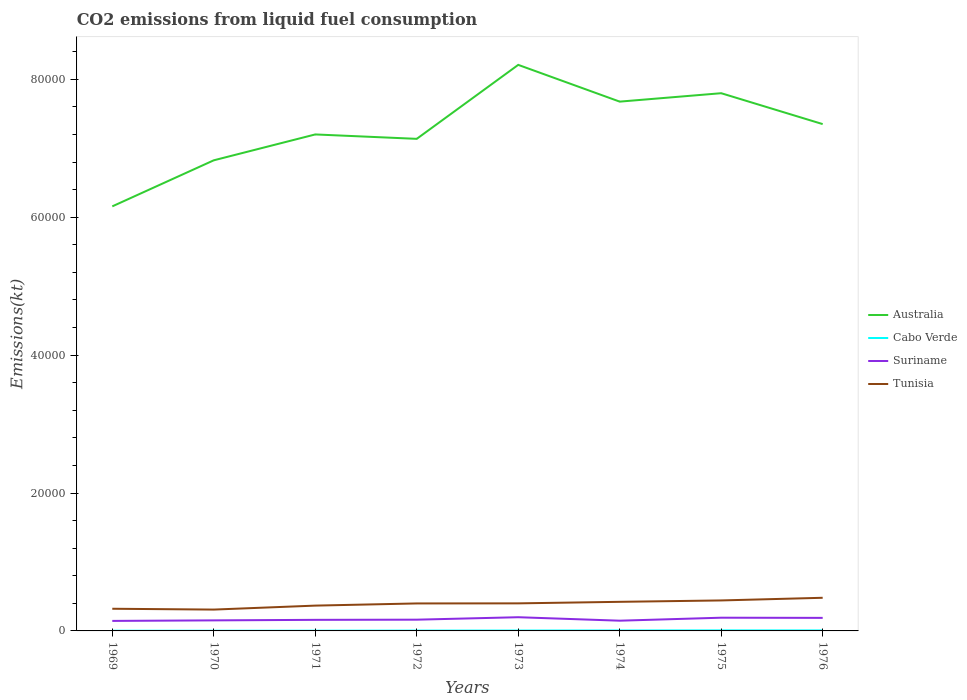Across all years, what is the maximum amount of CO2 emitted in Tunisia?
Ensure brevity in your answer.  3094.95. In which year was the amount of CO2 emitted in Cabo Verde maximum?
Keep it short and to the point. 1969. What is the total amount of CO2 emitted in Cabo Verde in the graph?
Ensure brevity in your answer.  0. What is the difference between the highest and the second highest amount of CO2 emitted in Australia?
Give a very brief answer. 2.05e+04. What is the difference between the highest and the lowest amount of CO2 emitted in Tunisia?
Provide a succinct answer. 5. Is the amount of CO2 emitted in Cabo Verde strictly greater than the amount of CO2 emitted in Tunisia over the years?
Your answer should be very brief. Yes. How many years are there in the graph?
Your answer should be very brief. 8. What is the difference between two consecutive major ticks on the Y-axis?
Offer a very short reply. 2.00e+04. Does the graph contain grids?
Keep it short and to the point. No. How many legend labels are there?
Ensure brevity in your answer.  4. What is the title of the graph?
Give a very brief answer. CO2 emissions from liquid fuel consumption. Does "Poland" appear as one of the legend labels in the graph?
Ensure brevity in your answer.  No. What is the label or title of the X-axis?
Make the answer very short. Years. What is the label or title of the Y-axis?
Make the answer very short. Emissions(kt). What is the Emissions(kt) in Australia in 1969?
Give a very brief answer. 6.16e+04. What is the Emissions(kt) of Cabo Verde in 1969?
Provide a short and direct response. 29.34. What is the Emissions(kt) of Suriname in 1969?
Ensure brevity in your answer.  1452.13. What is the Emissions(kt) of Tunisia in 1969?
Offer a terse response. 3215.96. What is the Emissions(kt) of Australia in 1970?
Make the answer very short. 6.83e+04. What is the Emissions(kt) in Cabo Verde in 1970?
Give a very brief answer. 29.34. What is the Emissions(kt) in Suriname in 1970?
Provide a succinct answer. 1529.14. What is the Emissions(kt) of Tunisia in 1970?
Provide a short and direct response. 3094.95. What is the Emissions(kt) of Australia in 1971?
Provide a succinct answer. 7.20e+04. What is the Emissions(kt) in Cabo Verde in 1971?
Make the answer very short. 33. What is the Emissions(kt) of Suriname in 1971?
Offer a terse response. 1606.15. What is the Emissions(kt) in Tunisia in 1971?
Keep it short and to the point. 3670.67. What is the Emissions(kt) in Australia in 1972?
Your response must be concise. 7.14e+04. What is the Emissions(kt) in Cabo Verde in 1972?
Offer a terse response. 47.67. What is the Emissions(kt) in Suriname in 1972?
Provide a succinct answer. 1631.82. What is the Emissions(kt) in Tunisia in 1972?
Give a very brief answer. 3986.03. What is the Emissions(kt) of Australia in 1973?
Offer a terse response. 8.21e+04. What is the Emissions(kt) of Cabo Verde in 1973?
Offer a very short reply. 55.01. What is the Emissions(kt) of Suriname in 1973?
Keep it short and to the point. 1987.51. What is the Emissions(kt) of Tunisia in 1973?
Provide a short and direct response. 3997.03. What is the Emissions(kt) of Australia in 1974?
Ensure brevity in your answer.  7.68e+04. What is the Emissions(kt) in Cabo Verde in 1974?
Offer a terse response. 66.01. What is the Emissions(kt) in Suriname in 1974?
Provide a succinct answer. 1485.13. What is the Emissions(kt) in Tunisia in 1974?
Make the answer very short. 4220.72. What is the Emissions(kt) of Australia in 1975?
Offer a very short reply. 7.80e+04. What is the Emissions(kt) in Cabo Verde in 1975?
Keep it short and to the point. 77.01. What is the Emissions(kt) in Suriname in 1975?
Provide a succinct answer. 1917.84. What is the Emissions(kt) in Tunisia in 1975?
Your answer should be very brief. 4422.4. What is the Emissions(kt) of Australia in 1976?
Offer a very short reply. 7.35e+04. What is the Emissions(kt) of Cabo Verde in 1976?
Keep it short and to the point. 73.34. What is the Emissions(kt) in Suriname in 1976?
Provide a short and direct response. 1892.17. What is the Emissions(kt) of Tunisia in 1976?
Give a very brief answer. 4807.44. Across all years, what is the maximum Emissions(kt) in Australia?
Your answer should be compact. 8.21e+04. Across all years, what is the maximum Emissions(kt) in Cabo Verde?
Your answer should be very brief. 77.01. Across all years, what is the maximum Emissions(kt) in Suriname?
Keep it short and to the point. 1987.51. Across all years, what is the maximum Emissions(kt) in Tunisia?
Provide a short and direct response. 4807.44. Across all years, what is the minimum Emissions(kt) in Australia?
Your answer should be very brief. 6.16e+04. Across all years, what is the minimum Emissions(kt) in Cabo Verde?
Provide a succinct answer. 29.34. Across all years, what is the minimum Emissions(kt) of Suriname?
Provide a succinct answer. 1452.13. Across all years, what is the minimum Emissions(kt) of Tunisia?
Provide a succinct answer. 3094.95. What is the total Emissions(kt) in Australia in the graph?
Offer a terse response. 5.84e+05. What is the total Emissions(kt) in Cabo Verde in the graph?
Your answer should be compact. 410.7. What is the total Emissions(kt) in Suriname in the graph?
Make the answer very short. 1.35e+04. What is the total Emissions(kt) of Tunisia in the graph?
Offer a very short reply. 3.14e+04. What is the difference between the Emissions(kt) in Australia in 1969 and that in 1970?
Keep it short and to the point. -6681.27. What is the difference between the Emissions(kt) in Suriname in 1969 and that in 1970?
Provide a succinct answer. -77.01. What is the difference between the Emissions(kt) of Tunisia in 1969 and that in 1970?
Make the answer very short. 121.01. What is the difference between the Emissions(kt) in Australia in 1969 and that in 1971?
Your answer should be compact. -1.04e+04. What is the difference between the Emissions(kt) in Cabo Verde in 1969 and that in 1971?
Give a very brief answer. -3.67. What is the difference between the Emissions(kt) in Suriname in 1969 and that in 1971?
Your answer should be very brief. -154.01. What is the difference between the Emissions(kt) of Tunisia in 1969 and that in 1971?
Your answer should be very brief. -454.71. What is the difference between the Emissions(kt) in Australia in 1969 and that in 1972?
Offer a terse response. -9794.56. What is the difference between the Emissions(kt) in Cabo Verde in 1969 and that in 1972?
Your answer should be compact. -18.34. What is the difference between the Emissions(kt) in Suriname in 1969 and that in 1972?
Offer a very short reply. -179.68. What is the difference between the Emissions(kt) in Tunisia in 1969 and that in 1972?
Ensure brevity in your answer.  -770.07. What is the difference between the Emissions(kt) of Australia in 1969 and that in 1973?
Offer a terse response. -2.05e+04. What is the difference between the Emissions(kt) of Cabo Verde in 1969 and that in 1973?
Keep it short and to the point. -25.67. What is the difference between the Emissions(kt) in Suriname in 1969 and that in 1973?
Provide a short and direct response. -535.38. What is the difference between the Emissions(kt) in Tunisia in 1969 and that in 1973?
Offer a very short reply. -781.07. What is the difference between the Emissions(kt) of Australia in 1969 and that in 1974?
Make the answer very short. -1.52e+04. What is the difference between the Emissions(kt) of Cabo Verde in 1969 and that in 1974?
Provide a short and direct response. -36.67. What is the difference between the Emissions(kt) of Suriname in 1969 and that in 1974?
Ensure brevity in your answer.  -33. What is the difference between the Emissions(kt) in Tunisia in 1969 and that in 1974?
Ensure brevity in your answer.  -1004.76. What is the difference between the Emissions(kt) of Australia in 1969 and that in 1975?
Offer a very short reply. -1.64e+04. What is the difference between the Emissions(kt) of Cabo Verde in 1969 and that in 1975?
Ensure brevity in your answer.  -47.67. What is the difference between the Emissions(kt) in Suriname in 1969 and that in 1975?
Make the answer very short. -465.71. What is the difference between the Emissions(kt) of Tunisia in 1969 and that in 1975?
Provide a succinct answer. -1206.44. What is the difference between the Emissions(kt) of Australia in 1969 and that in 1976?
Provide a succinct answer. -1.19e+04. What is the difference between the Emissions(kt) of Cabo Verde in 1969 and that in 1976?
Give a very brief answer. -44. What is the difference between the Emissions(kt) in Suriname in 1969 and that in 1976?
Provide a short and direct response. -440.04. What is the difference between the Emissions(kt) of Tunisia in 1969 and that in 1976?
Provide a succinct answer. -1591.48. What is the difference between the Emissions(kt) in Australia in 1970 and that in 1971?
Make the answer very short. -3751.34. What is the difference between the Emissions(kt) of Cabo Verde in 1970 and that in 1971?
Your answer should be compact. -3.67. What is the difference between the Emissions(kt) of Suriname in 1970 and that in 1971?
Your answer should be compact. -77.01. What is the difference between the Emissions(kt) in Tunisia in 1970 and that in 1971?
Provide a short and direct response. -575.72. What is the difference between the Emissions(kt) in Australia in 1970 and that in 1972?
Your answer should be compact. -3113.28. What is the difference between the Emissions(kt) in Cabo Verde in 1970 and that in 1972?
Make the answer very short. -18.34. What is the difference between the Emissions(kt) in Suriname in 1970 and that in 1972?
Make the answer very short. -102.68. What is the difference between the Emissions(kt) of Tunisia in 1970 and that in 1972?
Your response must be concise. -891.08. What is the difference between the Emissions(kt) of Australia in 1970 and that in 1973?
Make the answer very short. -1.38e+04. What is the difference between the Emissions(kt) in Cabo Verde in 1970 and that in 1973?
Your answer should be very brief. -25.67. What is the difference between the Emissions(kt) in Suriname in 1970 and that in 1973?
Keep it short and to the point. -458.38. What is the difference between the Emissions(kt) in Tunisia in 1970 and that in 1973?
Your answer should be very brief. -902.08. What is the difference between the Emissions(kt) in Australia in 1970 and that in 1974?
Your answer should be very brief. -8511.11. What is the difference between the Emissions(kt) of Cabo Verde in 1970 and that in 1974?
Provide a short and direct response. -36.67. What is the difference between the Emissions(kt) in Suriname in 1970 and that in 1974?
Your answer should be compact. 44. What is the difference between the Emissions(kt) of Tunisia in 1970 and that in 1974?
Your answer should be compact. -1125.77. What is the difference between the Emissions(kt) of Australia in 1970 and that in 1975?
Keep it short and to the point. -9732.22. What is the difference between the Emissions(kt) in Cabo Verde in 1970 and that in 1975?
Provide a short and direct response. -47.67. What is the difference between the Emissions(kt) in Suriname in 1970 and that in 1975?
Provide a succinct answer. -388.7. What is the difference between the Emissions(kt) of Tunisia in 1970 and that in 1975?
Offer a very short reply. -1327.45. What is the difference between the Emissions(kt) of Australia in 1970 and that in 1976?
Offer a very short reply. -5251.14. What is the difference between the Emissions(kt) of Cabo Verde in 1970 and that in 1976?
Give a very brief answer. -44. What is the difference between the Emissions(kt) of Suriname in 1970 and that in 1976?
Your answer should be compact. -363.03. What is the difference between the Emissions(kt) of Tunisia in 1970 and that in 1976?
Ensure brevity in your answer.  -1712.49. What is the difference between the Emissions(kt) of Australia in 1971 and that in 1972?
Keep it short and to the point. 638.06. What is the difference between the Emissions(kt) in Cabo Verde in 1971 and that in 1972?
Provide a succinct answer. -14.67. What is the difference between the Emissions(kt) in Suriname in 1971 and that in 1972?
Your answer should be very brief. -25.67. What is the difference between the Emissions(kt) of Tunisia in 1971 and that in 1972?
Your response must be concise. -315.36. What is the difference between the Emissions(kt) in Australia in 1971 and that in 1973?
Offer a very short reply. -1.01e+04. What is the difference between the Emissions(kt) of Cabo Verde in 1971 and that in 1973?
Provide a succinct answer. -22. What is the difference between the Emissions(kt) in Suriname in 1971 and that in 1973?
Ensure brevity in your answer.  -381.37. What is the difference between the Emissions(kt) of Tunisia in 1971 and that in 1973?
Make the answer very short. -326.36. What is the difference between the Emissions(kt) in Australia in 1971 and that in 1974?
Give a very brief answer. -4759.77. What is the difference between the Emissions(kt) of Cabo Verde in 1971 and that in 1974?
Your response must be concise. -33. What is the difference between the Emissions(kt) in Suriname in 1971 and that in 1974?
Give a very brief answer. 121.01. What is the difference between the Emissions(kt) of Tunisia in 1971 and that in 1974?
Your response must be concise. -550.05. What is the difference between the Emissions(kt) of Australia in 1971 and that in 1975?
Offer a terse response. -5980.88. What is the difference between the Emissions(kt) of Cabo Verde in 1971 and that in 1975?
Give a very brief answer. -44. What is the difference between the Emissions(kt) in Suriname in 1971 and that in 1975?
Your response must be concise. -311.69. What is the difference between the Emissions(kt) of Tunisia in 1971 and that in 1975?
Give a very brief answer. -751.74. What is the difference between the Emissions(kt) in Australia in 1971 and that in 1976?
Offer a very short reply. -1499.8. What is the difference between the Emissions(kt) of Cabo Verde in 1971 and that in 1976?
Your answer should be compact. -40.34. What is the difference between the Emissions(kt) in Suriname in 1971 and that in 1976?
Make the answer very short. -286.03. What is the difference between the Emissions(kt) in Tunisia in 1971 and that in 1976?
Your answer should be compact. -1136.77. What is the difference between the Emissions(kt) in Australia in 1972 and that in 1973?
Offer a very short reply. -1.07e+04. What is the difference between the Emissions(kt) of Cabo Verde in 1972 and that in 1973?
Your response must be concise. -7.33. What is the difference between the Emissions(kt) of Suriname in 1972 and that in 1973?
Offer a very short reply. -355.7. What is the difference between the Emissions(kt) in Tunisia in 1972 and that in 1973?
Your answer should be compact. -11. What is the difference between the Emissions(kt) of Australia in 1972 and that in 1974?
Offer a terse response. -5397.82. What is the difference between the Emissions(kt) in Cabo Verde in 1972 and that in 1974?
Give a very brief answer. -18.34. What is the difference between the Emissions(kt) in Suriname in 1972 and that in 1974?
Your response must be concise. 146.68. What is the difference between the Emissions(kt) in Tunisia in 1972 and that in 1974?
Provide a succinct answer. -234.69. What is the difference between the Emissions(kt) in Australia in 1972 and that in 1975?
Offer a very short reply. -6618.94. What is the difference between the Emissions(kt) in Cabo Verde in 1972 and that in 1975?
Offer a terse response. -29.34. What is the difference between the Emissions(kt) in Suriname in 1972 and that in 1975?
Offer a very short reply. -286.03. What is the difference between the Emissions(kt) of Tunisia in 1972 and that in 1975?
Provide a succinct answer. -436.37. What is the difference between the Emissions(kt) in Australia in 1972 and that in 1976?
Keep it short and to the point. -2137.86. What is the difference between the Emissions(kt) in Cabo Verde in 1972 and that in 1976?
Offer a terse response. -25.67. What is the difference between the Emissions(kt) in Suriname in 1972 and that in 1976?
Your answer should be very brief. -260.36. What is the difference between the Emissions(kt) of Tunisia in 1972 and that in 1976?
Keep it short and to the point. -821.41. What is the difference between the Emissions(kt) of Australia in 1973 and that in 1974?
Make the answer very short. 5331.82. What is the difference between the Emissions(kt) in Cabo Verde in 1973 and that in 1974?
Make the answer very short. -11. What is the difference between the Emissions(kt) of Suriname in 1973 and that in 1974?
Give a very brief answer. 502.38. What is the difference between the Emissions(kt) of Tunisia in 1973 and that in 1974?
Provide a short and direct response. -223.69. What is the difference between the Emissions(kt) in Australia in 1973 and that in 1975?
Keep it short and to the point. 4110.71. What is the difference between the Emissions(kt) of Cabo Verde in 1973 and that in 1975?
Offer a terse response. -22. What is the difference between the Emissions(kt) in Suriname in 1973 and that in 1975?
Give a very brief answer. 69.67. What is the difference between the Emissions(kt) of Tunisia in 1973 and that in 1975?
Make the answer very short. -425.37. What is the difference between the Emissions(kt) in Australia in 1973 and that in 1976?
Your answer should be very brief. 8591.78. What is the difference between the Emissions(kt) in Cabo Verde in 1973 and that in 1976?
Provide a succinct answer. -18.34. What is the difference between the Emissions(kt) of Suriname in 1973 and that in 1976?
Offer a very short reply. 95.34. What is the difference between the Emissions(kt) in Tunisia in 1973 and that in 1976?
Make the answer very short. -810.41. What is the difference between the Emissions(kt) of Australia in 1974 and that in 1975?
Your answer should be compact. -1221.11. What is the difference between the Emissions(kt) in Cabo Verde in 1974 and that in 1975?
Provide a short and direct response. -11. What is the difference between the Emissions(kt) of Suriname in 1974 and that in 1975?
Ensure brevity in your answer.  -432.71. What is the difference between the Emissions(kt) in Tunisia in 1974 and that in 1975?
Your response must be concise. -201.69. What is the difference between the Emissions(kt) of Australia in 1974 and that in 1976?
Ensure brevity in your answer.  3259.96. What is the difference between the Emissions(kt) of Cabo Verde in 1974 and that in 1976?
Your answer should be very brief. -7.33. What is the difference between the Emissions(kt) of Suriname in 1974 and that in 1976?
Give a very brief answer. -407.04. What is the difference between the Emissions(kt) of Tunisia in 1974 and that in 1976?
Offer a terse response. -586.72. What is the difference between the Emissions(kt) in Australia in 1975 and that in 1976?
Make the answer very short. 4481.07. What is the difference between the Emissions(kt) of Cabo Verde in 1975 and that in 1976?
Give a very brief answer. 3.67. What is the difference between the Emissions(kt) of Suriname in 1975 and that in 1976?
Provide a short and direct response. 25.67. What is the difference between the Emissions(kt) of Tunisia in 1975 and that in 1976?
Keep it short and to the point. -385.04. What is the difference between the Emissions(kt) of Australia in 1969 and the Emissions(kt) of Cabo Verde in 1970?
Offer a very short reply. 6.16e+04. What is the difference between the Emissions(kt) in Australia in 1969 and the Emissions(kt) in Suriname in 1970?
Give a very brief answer. 6.01e+04. What is the difference between the Emissions(kt) of Australia in 1969 and the Emissions(kt) of Tunisia in 1970?
Your answer should be very brief. 5.85e+04. What is the difference between the Emissions(kt) of Cabo Verde in 1969 and the Emissions(kt) of Suriname in 1970?
Offer a terse response. -1499.8. What is the difference between the Emissions(kt) in Cabo Verde in 1969 and the Emissions(kt) in Tunisia in 1970?
Offer a terse response. -3065.61. What is the difference between the Emissions(kt) in Suriname in 1969 and the Emissions(kt) in Tunisia in 1970?
Provide a succinct answer. -1642.82. What is the difference between the Emissions(kt) in Australia in 1969 and the Emissions(kt) in Cabo Verde in 1971?
Make the answer very short. 6.15e+04. What is the difference between the Emissions(kt) of Australia in 1969 and the Emissions(kt) of Suriname in 1971?
Provide a succinct answer. 6.00e+04. What is the difference between the Emissions(kt) in Australia in 1969 and the Emissions(kt) in Tunisia in 1971?
Ensure brevity in your answer.  5.79e+04. What is the difference between the Emissions(kt) in Cabo Verde in 1969 and the Emissions(kt) in Suriname in 1971?
Make the answer very short. -1576.81. What is the difference between the Emissions(kt) in Cabo Verde in 1969 and the Emissions(kt) in Tunisia in 1971?
Your answer should be very brief. -3641.33. What is the difference between the Emissions(kt) of Suriname in 1969 and the Emissions(kt) of Tunisia in 1971?
Keep it short and to the point. -2218.53. What is the difference between the Emissions(kt) in Australia in 1969 and the Emissions(kt) in Cabo Verde in 1972?
Your answer should be very brief. 6.15e+04. What is the difference between the Emissions(kt) in Australia in 1969 and the Emissions(kt) in Suriname in 1972?
Offer a very short reply. 5.99e+04. What is the difference between the Emissions(kt) of Australia in 1969 and the Emissions(kt) of Tunisia in 1972?
Your response must be concise. 5.76e+04. What is the difference between the Emissions(kt) in Cabo Verde in 1969 and the Emissions(kt) in Suriname in 1972?
Ensure brevity in your answer.  -1602.48. What is the difference between the Emissions(kt) in Cabo Verde in 1969 and the Emissions(kt) in Tunisia in 1972?
Your response must be concise. -3956.69. What is the difference between the Emissions(kt) of Suriname in 1969 and the Emissions(kt) of Tunisia in 1972?
Your answer should be very brief. -2533.9. What is the difference between the Emissions(kt) of Australia in 1969 and the Emissions(kt) of Cabo Verde in 1973?
Ensure brevity in your answer.  6.15e+04. What is the difference between the Emissions(kt) of Australia in 1969 and the Emissions(kt) of Suriname in 1973?
Keep it short and to the point. 5.96e+04. What is the difference between the Emissions(kt) in Australia in 1969 and the Emissions(kt) in Tunisia in 1973?
Provide a succinct answer. 5.76e+04. What is the difference between the Emissions(kt) of Cabo Verde in 1969 and the Emissions(kt) of Suriname in 1973?
Your answer should be very brief. -1958.18. What is the difference between the Emissions(kt) in Cabo Verde in 1969 and the Emissions(kt) in Tunisia in 1973?
Your response must be concise. -3967.69. What is the difference between the Emissions(kt) of Suriname in 1969 and the Emissions(kt) of Tunisia in 1973?
Ensure brevity in your answer.  -2544.9. What is the difference between the Emissions(kt) in Australia in 1969 and the Emissions(kt) in Cabo Verde in 1974?
Ensure brevity in your answer.  6.15e+04. What is the difference between the Emissions(kt) in Australia in 1969 and the Emissions(kt) in Suriname in 1974?
Your answer should be compact. 6.01e+04. What is the difference between the Emissions(kt) of Australia in 1969 and the Emissions(kt) of Tunisia in 1974?
Make the answer very short. 5.74e+04. What is the difference between the Emissions(kt) of Cabo Verde in 1969 and the Emissions(kt) of Suriname in 1974?
Provide a succinct answer. -1455.8. What is the difference between the Emissions(kt) of Cabo Verde in 1969 and the Emissions(kt) of Tunisia in 1974?
Your answer should be compact. -4191.38. What is the difference between the Emissions(kt) of Suriname in 1969 and the Emissions(kt) of Tunisia in 1974?
Give a very brief answer. -2768.59. What is the difference between the Emissions(kt) of Australia in 1969 and the Emissions(kt) of Cabo Verde in 1975?
Provide a short and direct response. 6.15e+04. What is the difference between the Emissions(kt) in Australia in 1969 and the Emissions(kt) in Suriname in 1975?
Offer a terse response. 5.97e+04. What is the difference between the Emissions(kt) of Australia in 1969 and the Emissions(kt) of Tunisia in 1975?
Offer a terse response. 5.72e+04. What is the difference between the Emissions(kt) in Cabo Verde in 1969 and the Emissions(kt) in Suriname in 1975?
Make the answer very short. -1888.51. What is the difference between the Emissions(kt) in Cabo Verde in 1969 and the Emissions(kt) in Tunisia in 1975?
Give a very brief answer. -4393.07. What is the difference between the Emissions(kt) in Suriname in 1969 and the Emissions(kt) in Tunisia in 1975?
Your answer should be compact. -2970.27. What is the difference between the Emissions(kt) of Australia in 1969 and the Emissions(kt) of Cabo Verde in 1976?
Keep it short and to the point. 6.15e+04. What is the difference between the Emissions(kt) in Australia in 1969 and the Emissions(kt) in Suriname in 1976?
Your answer should be compact. 5.97e+04. What is the difference between the Emissions(kt) of Australia in 1969 and the Emissions(kt) of Tunisia in 1976?
Make the answer very short. 5.68e+04. What is the difference between the Emissions(kt) in Cabo Verde in 1969 and the Emissions(kt) in Suriname in 1976?
Your response must be concise. -1862.84. What is the difference between the Emissions(kt) in Cabo Verde in 1969 and the Emissions(kt) in Tunisia in 1976?
Your answer should be compact. -4778.1. What is the difference between the Emissions(kt) of Suriname in 1969 and the Emissions(kt) of Tunisia in 1976?
Provide a succinct answer. -3355.3. What is the difference between the Emissions(kt) in Australia in 1970 and the Emissions(kt) in Cabo Verde in 1971?
Give a very brief answer. 6.82e+04. What is the difference between the Emissions(kt) of Australia in 1970 and the Emissions(kt) of Suriname in 1971?
Your response must be concise. 6.67e+04. What is the difference between the Emissions(kt) of Australia in 1970 and the Emissions(kt) of Tunisia in 1971?
Offer a very short reply. 6.46e+04. What is the difference between the Emissions(kt) of Cabo Verde in 1970 and the Emissions(kt) of Suriname in 1971?
Offer a terse response. -1576.81. What is the difference between the Emissions(kt) of Cabo Verde in 1970 and the Emissions(kt) of Tunisia in 1971?
Offer a very short reply. -3641.33. What is the difference between the Emissions(kt) of Suriname in 1970 and the Emissions(kt) of Tunisia in 1971?
Keep it short and to the point. -2141.53. What is the difference between the Emissions(kt) of Australia in 1970 and the Emissions(kt) of Cabo Verde in 1972?
Make the answer very short. 6.82e+04. What is the difference between the Emissions(kt) in Australia in 1970 and the Emissions(kt) in Suriname in 1972?
Ensure brevity in your answer.  6.66e+04. What is the difference between the Emissions(kt) in Australia in 1970 and the Emissions(kt) in Tunisia in 1972?
Your answer should be compact. 6.43e+04. What is the difference between the Emissions(kt) of Cabo Verde in 1970 and the Emissions(kt) of Suriname in 1972?
Your response must be concise. -1602.48. What is the difference between the Emissions(kt) of Cabo Verde in 1970 and the Emissions(kt) of Tunisia in 1972?
Your response must be concise. -3956.69. What is the difference between the Emissions(kt) of Suriname in 1970 and the Emissions(kt) of Tunisia in 1972?
Your answer should be compact. -2456.89. What is the difference between the Emissions(kt) in Australia in 1970 and the Emissions(kt) in Cabo Verde in 1973?
Your answer should be very brief. 6.82e+04. What is the difference between the Emissions(kt) in Australia in 1970 and the Emissions(kt) in Suriname in 1973?
Make the answer very short. 6.63e+04. What is the difference between the Emissions(kt) in Australia in 1970 and the Emissions(kt) in Tunisia in 1973?
Provide a succinct answer. 6.43e+04. What is the difference between the Emissions(kt) in Cabo Verde in 1970 and the Emissions(kt) in Suriname in 1973?
Your answer should be compact. -1958.18. What is the difference between the Emissions(kt) of Cabo Verde in 1970 and the Emissions(kt) of Tunisia in 1973?
Ensure brevity in your answer.  -3967.69. What is the difference between the Emissions(kt) of Suriname in 1970 and the Emissions(kt) of Tunisia in 1973?
Offer a terse response. -2467.89. What is the difference between the Emissions(kt) in Australia in 1970 and the Emissions(kt) in Cabo Verde in 1974?
Make the answer very short. 6.82e+04. What is the difference between the Emissions(kt) in Australia in 1970 and the Emissions(kt) in Suriname in 1974?
Your response must be concise. 6.68e+04. What is the difference between the Emissions(kt) in Australia in 1970 and the Emissions(kt) in Tunisia in 1974?
Offer a terse response. 6.40e+04. What is the difference between the Emissions(kt) of Cabo Verde in 1970 and the Emissions(kt) of Suriname in 1974?
Provide a succinct answer. -1455.8. What is the difference between the Emissions(kt) in Cabo Verde in 1970 and the Emissions(kt) in Tunisia in 1974?
Your answer should be compact. -4191.38. What is the difference between the Emissions(kt) in Suriname in 1970 and the Emissions(kt) in Tunisia in 1974?
Provide a succinct answer. -2691.58. What is the difference between the Emissions(kt) in Australia in 1970 and the Emissions(kt) in Cabo Verde in 1975?
Provide a short and direct response. 6.82e+04. What is the difference between the Emissions(kt) in Australia in 1970 and the Emissions(kt) in Suriname in 1975?
Your answer should be very brief. 6.63e+04. What is the difference between the Emissions(kt) of Australia in 1970 and the Emissions(kt) of Tunisia in 1975?
Make the answer very short. 6.38e+04. What is the difference between the Emissions(kt) in Cabo Verde in 1970 and the Emissions(kt) in Suriname in 1975?
Keep it short and to the point. -1888.51. What is the difference between the Emissions(kt) of Cabo Verde in 1970 and the Emissions(kt) of Tunisia in 1975?
Make the answer very short. -4393.07. What is the difference between the Emissions(kt) in Suriname in 1970 and the Emissions(kt) in Tunisia in 1975?
Your response must be concise. -2893.26. What is the difference between the Emissions(kt) of Australia in 1970 and the Emissions(kt) of Cabo Verde in 1976?
Make the answer very short. 6.82e+04. What is the difference between the Emissions(kt) of Australia in 1970 and the Emissions(kt) of Suriname in 1976?
Your response must be concise. 6.64e+04. What is the difference between the Emissions(kt) in Australia in 1970 and the Emissions(kt) in Tunisia in 1976?
Ensure brevity in your answer.  6.35e+04. What is the difference between the Emissions(kt) of Cabo Verde in 1970 and the Emissions(kt) of Suriname in 1976?
Ensure brevity in your answer.  -1862.84. What is the difference between the Emissions(kt) in Cabo Verde in 1970 and the Emissions(kt) in Tunisia in 1976?
Provide a short and direct response. -4778.1. What is the difference between the Emissions(kt) in Suriname in 1970 and the Emissions(kt) in Tunisia in 1976?
Ensure brevity in your answer.  -3278.3. What is the difference between the Emissions(kt) of Australia in 1971 and the Emissions(kt) of Cabo Verde in 1972?
Provide a succinct answer. 7.20e+04. What is the difference between the Emissions(kt) in Australia in 1971 and the Emissions(kt) in Suriname in 1972?
Provide a succinct answer. 7.04e+04. What is the difference between the Emissions(kt) of Australia in 1971 and the Emissions(kt) of Tunisia in 1972?
Your answer should be compact. 6.80e+04. What is the difference between the Emissions(kt) in Cabo Verde in 1971 and the Emissions(kt) in Suriname in 1972?
Your answer should be very brief. -1598.81. What is the difference between the Emissions(kt) in Cabo Verde in 1971 and the Emissions(kt) in Tunisia in 1972?
Ensure brevity in your answer.  -3953.03. What is the difference between the Emissions(kt) in Suriname in 1971 and the Emissions(kt) in Tunisia in 1972?
Give a very brief answer. -2379.88. What is the difference between the Emissions(kt) in Australia in 1971 and the Emissions(kt) in Cabo Verde in 1973?
Your answer should be very brief. 7.20e+04. What is the difference between the Emissions(kt) of Australia in 1971 and the Emissions(kt) of Suriname in 1973?
Give a very brief answer. 7.00e+04. What is the difference between the Emissions(kt) of Australia in 1971 and the Emissions(kt) of Tunisia in 1973?
Make the answer very short. 6.80e+04. What is the difference between the Emissions(kt) in Cabo Verde in 1971 and the Emissions(kt) in Suriname in 1973?
Ensure brevity in your answer.  -1954.51. What is the difference between the Emissions(kt) of Cabo Verde in 1971 and the Emissions(kt) of Tunisia in 1973?
Ensure brevity in your answer.  -3964.03. What is the difference between the Emissions(kt) of Suriname in 1971 and the Emissions(kt) of Tunisia in 1973?
Make the answer very short. -2390.88. What is the difference between the Emissions(kt) in Australia in 1971 and the Emissions(kt) in Cabo Verde in 1974?
Your response must be concise. 7.19e+04. What is the difference between the Emissions(kt) in Australia in 1971 and the Emissions(kt) in Suriname in 1974?
Your answer should be compact. 7.05e+04. What is the difference between the Emissions(kt) in Australia in 1971 and the Emissions(kt) in Tunisia in 1974?
Provide a short and direct response. 6.78e+04. What is the difference between the Emissions(kt) in Cabo Verde in 1971 and the Emissions(kt) in Suriname in 1974?
Offer a very short reply. -1452.13. What is the difference between the Emissions(kt) in Cabo Verde in 1971 and the Emissions(kt) in Tunisia in 1974?
Give a very brief answer. -4187.71. What is the difference between the Emissions(kt) in Suriname in 1971 and the Emissions(kt) in Tunisia in 1974?
Your answer should be compact. -2614.57. What is the difference between the Emissions(kt) in Australia in 1971 and the Emissions(kt) in Cabo Verde in 1975?
Your response must be concise. 7.19e+04. What is the difference between the Emissions(kt) in Australia in 1971 and the Emissions(kt) in Suriname in 1975?
Provide a short and direct response. 7.01e+04. What is the difference between the Emissions(kt) of Australia in 1971 and the Emissions(kt) of Tunisia in 1975?
Offer a terse response. 6.76e+04. What is the difference between the Emissions(kt) of Cabo Verde in 1971 and the Emissions(kt) of Suriname in 1975?
Keep it short and to the point. -1884.84. What is the difference between the Emissions(kt) in Cabo Verde in 1971 and the Emissions(kt) in Tunisia in 1975?
Give a very brief answer. -4389.4. What is the difference between the Emissions(kt) of Suriname in 1971 and the Emissions(kt) of Tunisia in 1975?
Make the answer very short. -2816.26. What is the difference between the Emissions(kt) of Australia in 1971 and the Emissions(kt) of Cabo Verde in 1976?
Your answer should be compact. 7.19e+04. What is the difference between the Emissions(kt) of Australia in 1971 and the Emissions(kt) of Suriname in 1976?
Ensure brevity in your answer.  7.01e+04. What is the difference between the Emissions(kt) of Australia in 1971 and the Emissions(kt) of Tunisia in 1976?
Offer a very short reply. 6.72e+04. What is the difference between the Emissions(kt) of Cabo Verde in 1971 and the Emissions(kt) of Suriname in 1976?
Offer a very short reply. -1859.17. What is the difference between the Emissions(kt) of Cabo Verde in 1971 and the Emissions(kt) of Tunisia in 1976?
Make the answer very short. -4774.43. What is the difference between the Emissions(kt) in Suriname in 1971 and the Emissions(kt) in Tunisia in 1976?
Your answer should be compact. -3201.29. What is the difference between the Emissions(kt) of Australia in 1972 and the Emissions(kt) of Cabo Verde in 1973?
Your answer should be very brief. 7.13e+04. What is the difference between the Emissions(kt) of Australia in 1972 and the Emissions(kt) of Suriname in 1973?
Keep it short and to the point. 6.94e+04. What is the difference between the Emissions(kt) in Australia in 1972 and the Emissions(kt) in Tunisia in 1973?
Provide a succinct answer. 6.74e+04. What is the difference between the Emissions(kt) in Cabo Verde in 1972 and the Emissions(kt) in Suriname in 1973?
Provide a short and direct response. -1939.84. What is the difference between the Emissions(kt) in Cabo Verde in 1972 and the Emissions(kt) in Tunisia in 1973?
Ensure brevity in your answer.  -3949.36. What is the difference between the Emissions(kt) of Suriname in 1972 and the Emissions(kt) of Tunisia in 1973?
Your answer should be very brief. -2365.22. What is the difference between the Emissions(kt) in Australia in 1972 and the Emissions(kt) in Cabo Verde in 1974?
Provide a short and direct response. 7.13e+04. What is the difference between the Emissions(kt) of Australia in 1972 and the Emissions(kt) of Suriname in 1974?
Ensure brevity in your answer.  6.99e+04. What is the difference between the Emissions(kt) in Australia in 1972 and the Emissions(kt) in Tunisia in 1974?
Provide a succinct answer. 6.72e+04. What is the difference between the Emissions(kt) in Cabo Verde in 1972 and the Emissions(kt) in Suriname in 1974?
Ensure brevity in your answer.  -1437.46. What is the difference between the Emissions(kt) in Cabo Verde in 1972 and the Emissions(kt) in Tunisia in 1974?
Give a very brief answer. -4173.05. What is the difference between the Emissions(kt) of Suriname in 1972 and the Emissions(kt) of Tunisia in 1974?
Your answer should be very brief. -2588.9. What is the difference between the Emissions(kt) in Australia in 1972 and the Emissions(kt) in Cabo Verde in 1975?
Your answer should be very brief. 7.13e+04. What is the difference between the Emissions(kt) in Australia in 1972 and the Emissions(kt) in Suriname in 1975?
Give a very brief answer. 6.95e+04. What is the difference between the Emissions(kt) in Australia in 1972 and the Emissions(kt) in Tunisia in 1975?
Offer a very short reply. 6.70e+04. What is the difference between the Emissions(kt) in Cabo Verde in 1972 and the Emissions(kt) in Suriname in 1975?
Keep it short and to the point. -1870.17. What is the difference between the Emissions(kt) of Cabo Verde in 1972 and the Emissions(kt) of Tunisia in 1975?
Offer a very short reply. -4374.73. What is the difference between the Emissions(kt) in Suriname in 1972 and the Emissions(kt) in Tunisia in 1975?
Ensure brevity in your answer.  -2790.59. What is the difference between the Emissions(kt) of Australia in 1972 and the Emissions(kt) of Cabo Verde in 1976?
Provide a succinct answer. 7.13e+04. What is the difference between the Emissions(kt) in Australia in 1972 and the Emissions(kt) in Suriname in 1976?
Provide a succinct answer. 6.95e+04. What is the difference between the Emissions(kt) of Australia in 1972 and the Emissions(kt) of Tunisia in 1976?
Keep it short and to the point. 6.66e+04. What is the difference between the Emissions(kt) in Cabo Verde in 1972 and the Emissions(kt) in Suriname in 1976?
Your answer should be compact. -1844.5. What is the difference between the Emissions(kt) of Cabo Verde in 1972 and the Emissions(kt) of Tunisia in 1976?
Your answer should be compact. -4759.77. What is the difference between the Emissions(kt) of Suriname in 1972 and the Emissions(kt) of Tunisia in 1976?
Keep it short and to the point. -3175.62. What is the difference between the Emissions(kt) in Australia in 1973 and the Emissions(kt) in Cabo Verde in 1974?
Offer a terse response. 8.20e+04. What is the difference between the Emissions(kt) of Australia in 1973 and the Emissions(kt) of Suriname in 1974?
Your response must be concise. 8.06e+04. What is the difference between the Emissions(kt) in Australia in 1973 and the Emissions(kt) in Tunisia in 1974?
Provide a succinct answer. 7.79e+04. What is the difference between the Emissions(kt) of Cabo Verde in 1973 and the Emissions(kt) of Suriname in 1974?
Offer a terse response. -1430.13. What is the difference between the Emissions(kt) in Cabo Verde in 1973 and the Emissions(kt) in Tunisia in 1974?
Keep it short and to the point. -4165.71. What is the difference between the Emissions(kt) in Suriname in 1973 and the Emissions(kt) in Tunisia in 1974?
Your answer should be compact. -2233.2. What is the difference between the Emissions(kt) of Australia in 1973 and the Emissions(kt) of Cabo Verde in 1975?
Offer a very short reply. 8.20e+04. What is the difference between the Emissions(kt) of Australia in 1973 and the Emissions(kt) of Suriname in 1975?
Ensure brevity in your answer.  8.02e+04. What is the difference between the Emissions(kt) in Australia in 1973 and the Emissions(kt) in Tunisia in 1975?
Ensure brevity in your answer.  7.77e+04. What is the difference between the Emissions(kt) of Cabo Verde in 1973 and the Emissions(kt) of Suriname in 1975?
Offer a terse response. -1862.84. What is the difference between the Emissions(kt) of Cabo Verde in 1973 and the Emissions(kt) of Tunisia in 1975?
Provide a succinct answer. -4367.4. What is the difference between the Emissions(kt) of Suriname in 1973 and the Emissions(kt) of Tunisia in 1975?
Your response must be concise. -2434.89. What is the difference between the Emissions(kt) of Australia in 1973 and the Emissions(kt) of Cabo Verde in 1976?
Provide a short and direct response. 8.20e+04. What is the difference between the Emissions(kt) of Australia in 1973 and the Emissions(kt) of Suriname in 1976?
Provide a succinct answer. 8.02e+04. What is the difference between the Emissions(kt) in Australia in 1973 and the Emissions(kt) in Tunisia in 1976?
Make the answer very short. 7.73e+04. What is the difference between the Emissions(kt) in Cabo Verde in 1973 and the Emissions(kt) in Suriname in 1976?
Your answer should be compact. -1837.17. What is the difference between the Emissions(kt) of Cabo Verde in 1973 and the Emissions(kt) of Tunisia in 1976?
Your answer should be very brief. -4752.43. What is the difference between the Emissions(kt) of Suriname in 1973 and the Emissions(kt) of Tunisia in 1976?
Provide a succinct answer. -2819.92. What is the difference between the Emissions(kt) in Australia in 1974 and the Emissions(kt) in Cabo Verde in 1975?
Make the answer very short. 7.67e+04. What is the difference between the Emissions(kt) of Australia in 1974 and the Emissions(kt) of Suriname in 1975?
Give a very brief answer. 7.49e+04. What is the difference between the Emissions(kt) in Australia in 1974 and the Emissions(kt) in Tunisia in 1975?
Offer a terse response. 7.23e+04. What is the difference between the Emissions(kt) of Cabo Verde in 1974 and the Emissions(kt) of Suriname in 1975?
Keep it short and to the point. -1851.84. What is the difference between the Emissions(kt) of Cabo Verde in 1974 and the Emissions(kt) of Tunisia in 1975?
Make the answer very short. -4356.4. What is the difference between the Emissions(kt) in Suriname in 1974 and the Emissions(kt) in Tunisia in 1975?
Give a very brief answer. -2937.27. What is the difference between the Emissions(kt) of Australia in 1974 and the Emissions(kt) of Cabo Verde in 1976?
Make the answer very short. 7.67e+04. What is the difference between the Emissions(kt) of Australia in 1974 and the Emissions(kt) of Suriname in 1976?
Give a very brief answer. 7.49e+04. What is the difference between the Emissions(kt) in Australia in 1974 and the Emissions(kt) in Tunisia in 1976?
Provide a succinct answer. 7.20e+04. What is the difference between the Emissions(kt) of Cabo Verde in 1974 and the Emissions(kt) of Suriname in 1976?
Provide a short and direct response. -1826.17. What is the difference between the Emissions(kt) in Cabo Verde in 1974 and the Emissions(kt) in Tunisia in 1976?
Keep it short and to the point. -4741.43. What is the difference between the Emissions(kt) of Suriname in 1974 and the Emissions(kt) of Tunisia in 1976?
Offer a terse response. -3322.3. What is the difference between the Emissions(kt) of Australia in 1975 and the Emissions(kt) of Cabo Verde in 1976?
Your response must be concise. 7.79e+04. What is the difference between the Emissions(kt) in Australia in 1975 and the Emissions(kt) in Suriname in 1976?
Keep it short and to the point. 7.61e+04. What is the difference between the Emissions(kt) of Australia in 1975 and the Emissions(kt) of Tunisia in 1976?
Offer a terse response. 7.32e+04. What is the difference between the Emissions(kt) of Cabo Verde in 1975 and the Emissions(kt) of Suriname in 1976?
Make the answer very short. -1815.16. What is the difference between the Emissions(kt) of Cabo Verde in 1975 and the Emissions(kt) of Tunisia in 1976?
Provide a succinct answer. -4730.43. What is the difference between the Emissions(kt) of Suriname in 1975 and the Emissions(kt) of Tunisia in 1976?
Offer a terse response. -2889.6. What is the average Emissions(kt) of Australia per year?
Your answer should be very brief. 7.30e+04. What is the average Emissions(kt) in Cabo Verde per year?
Provide a succinct answer. 51.34. What is the average Emissions(kt) in Suriname per year?
Provide a short and direct response. 1687.74. What is the average Emissions(kt) in Tunisia per year?
Provide a succinct answer. 3926.9. In the year 1969, what is the difference between the Emissions(kt) in Australia and Emissions(kt) in Cabo Verde?
Keep it short and to the point. 6.16e+04. In the year 1969, what is the difference between the Emissions(kt) of Australia and Emissions(kt) of Suriname?
Make the answer very short. 6.01e+04. In the year 1969, what is the difference between the Emissions(kt) of Australia and Emissions(kt) of Tunisia?
Provide a succinct answer. 5.84e+04. In the year 1969, what is the difference between the Emissions(kt) in Cabo Verde and Emissions(kt) in Suriname?
Your response must be concise. -1422.8. In the year 1969, what is the difference between the Emissions(kt) of Cabo Verde and Emissions(kt) of Tunisia?
Give a very brief answer. -3186.62. In the year 1969, what is the difference between the Emissions(kt) in Suriname and Emissions(kt) in Tunisia?
Ensure brevity in your answer.  -1763.83. In the year 1970, what is the difference between the Emissions(kt) in Australia and Emissions(kt) in Cabo Verde?
Your answer should be very brief. 6.82e+04. In the year 1970, what is the difference between the Emissions(kt) of Australia and Emissions(kt) of Suriname?
Make the answer very short. 6.67e+04. In the year 1970, what is the difference between the Emissions(kt) of Australia and Emissions(kt) of Tunisia?
Offer a terse response. 6.52e+04. In the year 1970, what is the difference between the Emissions(kt) of Cabo Verde and Emissions(kt) of Suriname?
Provide a short and direct response. -1499.8. In the year 1970, what is the difference between the Emissions(kt) in Cabo Verde and Emissions(kt) in Tunisia?
Ensure brevity in your answer.  -3065.61. In the year 1970, what is the difference between the Emissions(kt) of Suriname and Emissions(kt) of Tunisia?
Offer a terse response. -1565.81. In the year 1971, what is the difference between the Emissions(kt) of Australia and Emissions(kt) of Cabo Verde?
Give a very brief answer. 7.20e+04. In the year 1971, what is the difference between the Emissions(kt) of Australia and Emissions(kt) of Suriname?
Your response must be concise. 7.04e+04. In the year 1971, what is the difference between the Emissions(kt) in Australia and Emissions(kt) in Tunisia?
Give a very brief answer. 6.83e+04. In the year 1971, what is the difference between the Emissions(kt) in Cabo Verde and Emissions(kt) in Suriname?
Keep it short and to the point. -1573.14. In the year 1971, what is the difference between the Emissions(kt) in Cabo Verde and Emissions(kt) in Tunisia?
Keep it short and to the point. -3637.66. In the year 1971, what is the difference between the Emissions(kt) of Suriname and Emissions(kt) of Tunisia?
Offer a very short reply. -2064.52. In the year 1972, what is the difference between the Emissions(kt) of Australia and Emissions(kt) of Cabo Verde?
Your answer should be very brief. 7.13e+04. In the year 1972, what is the difference between the Emissions(kt) in Australia and Emissions(kt) in Suriname?
Keep it short and to the point. 6.97e+04. In the year 1972, what is the difference between the Emissions(kt) of Australia and Emissions(kt) of Tunisia?
Make the answer very short. 6.74e+04. In the year 1972, what is the difference between the Emissions(kt) in Cabo Verde and Emissions(kt) in Suriname?
Offer a terse response. -1584.14. In the year 1972, what is the difference between the Emissions(kt) in Cabo Verde and Emissions(kt) in Tunisia?
Offer a very short reply. -3938.36. In the year 1972, what is the difference between the Emissions(kt) in Suriname and Emissions(kt) in Tunisia?
Ensure brevity in your answer.  -2354.21. In the year 1973, what is the difference between the Emissions(kt) of Australia and Emissions(kt) of Cabo Verde?
Give a very brief answer. 8.20e+04. In the year 1973, what is the difference between the Emissions(kt) in Australia and Emissions(kt) in Suriname?
Your answer should be compact. 8.01e+04. In the year 1973, what is the difference between the Emissions(kt) of Australia and Emissions(kt) of Tunisia?
Your answer should be very brief. 7.81e+04. In the year 1973, what is the difference between the Emissions(kt) of Cabo Verde and Emissions(kt) of Suriname?
Give a very brief answer. -1932.51. In the year 1973, what is the difference between the Emissions(kt) in Cabo Verde and Emissions(kt) in Tunisia?
Provide a short and direct response. -3942.03. In the year 1973, what is the difference between the Emissions(kt) in Suriname and Emissions(kt) in Tunisia?
Your answer should be very brief. -2009.52. In the year 1974, what is the difference between the Emissions(kt) of Australia and Emissions(kt) of Cabo Verde?
Your answer should be very brief. 7.67e+04. In the year 1974, what is the difference between the Emissions(kt) of Australia and Emissions(kt) of Suriname?
Provide a succinct answer. 7.53e+04. In the year 1974, what is the difference between the Emissions(kt) in Australia and Emissions(kt) in Tunisia?
Provide a short and direct response. 7.26e+04. In the year 1974, what is the difference between the Emissions(kt) in Cabo Verde and Emissions(kt) in Suriname?
Your answer should be compact. -1419.13. In the year 1974, what is the difference between the Emissions(kt) of Cabo Verde and Emissions(kt) of Tunisia?
Offer a terse response. -4154.71. In the year 1974, what is the difference between the Emissions(kt) in Suriname and Emissions(kt) in Tunisia?
Ensure brevity in your answer.  -2735.58. In the year 1975, what is the difference between the Emissions(kt) of Australia and Emissions(kt) of Cabo Verde?
Provide a short and direct response. 7.79e+04. In the year 1975, what is the difference between the Emissions(kt) of Australia and Emissions(kt) of Suriname?
Give a very brief answer. 7.61e+04. In the year 1975, what is the difference between the Emissions(kt) in Australia and Emissions(kt) in Tunisia?
Your response must be concise. 7.36e+04. In the year 1975, what is the difference between the Emissions(kt) of Cabo Verde and Emissions(kt) of Suriname?
Give a very brief answer. -1840.83. In the year 1975, what is the difference between the Emissions(kt) in Cabo Verde and Emissions(kt) in Tunisia?
Offer a terse response. -4345.4. In the year 1975, what is the difference between the Emissions(kt) of Suriname and Emissions(kt) of Tunisia?
Provide a succinct answer. -2504.56. In the year 1976, what is the difference between the Emissions(kt) in Australia and Emissions(kt) in Cabo Verde?
Keep it short and to the point. 7.34e+04. In the year 1976, what is the difference between the Emissions(kt) of Australia and Emissions(kt) of Suriname?
Make the answer very short. 7.16e+04. In the year 1976, what is the difference between the Emissions(kt) in Australia and Emissions(kt) in Tunisia?
Your response must be concise. 6.87e+04. In the year 1976, what is the difference between the Emissions(kt) of Cabo Verde and Emissions(kt) of Suriname?
Ensure brevity in your answer.  -1818.83. In the year 1976, what is the difference between the Emissions(kt) in Cabo Verde and Emissions(kt) in Tunisia?
Provide a short and direct response. -4734.1. In the year 1976, what is the difference between the Emissions(kt) of Suriname and Emissions(kt) of Tunisia?
Ensure brevity in your answer.  -2915.26. What is the ratio of the Emissions(kt) of Australia in 1969 to that in 1970?
Provide a short and direct response. 0.9. What is the ratio of the Emissions(kt) in Suriname in 1969 to that in 1970?
Provide a succinct answer. 0.95. What is the ratio of the Emissions(kt) in Tunisia in 1969 to that in 1970?
Your answer should be compact. 1.04. What is the ratio of the Emissions(kt) of Australia in 1969 to that in 1971?
Offer a terse response. 0.86. What is the ratio of the Emissions(kt) of Cabo Verde in 1969 to that in 1971?
Provide a short and direct response. 0.89. What is the ratio of the Emissions(kt) of Suriname in 1969 to that in 1971?
Offer a terse response. 0.9. What is the ratio of the Emissions(kt) in Tunisia in 1969 to that in 1971?
Offer a terse response. 0.88. What is the ratio of the Emissions(kt) of Australia in 1969 to that in 1972?
Give a very brief answer. 0.86. What is the ratio of the Emissions(kt) in Cabo Verde in 1969 to that in 1972?
Keep it short and to the point. 0.62. What is the ratio of the Emissions(kt) in Suriname in 1969 to that in 1972?
Make the answer very short. 0.89. What is the ratio of the Emissions(kt) in Tunisia in 1969 to that in 1972?
Your response must be concise. 0.81. What is the ratio of the Emissions(kt) in Australia in 1969 to that in 1973?
Your response must be concise. 0.75. What is the ratio of the Emissions(kt) in Cabo Verde in 1969 to that in 1973?
Your response must be concise. 0.53. What is the ratio of the Emissions(kt) in Suriname in 1969 to that in 1973?
Provide a short and direct response. 0.73. What is the ratio of the Emissions(kt) in Tunisia in 1969 to that in 1973?
Your answer should be very brief. 0.8. What is the ratio of the Emissions(kt) in Australia in 1969 to that in 1974?
Make the answer very short. 0.8. What is the ratio of the Emissions(kt) in Cabo Verde in 1969 to that in 1974?
Make the answer very short. 0.44. What is the ratio of the Emissions(kt) in Suriname in 1969 to that in 1974?
Provide a short and direct response. 0.98. What is the ratio of the Emissions(kt) in Tunisia in 1969 to that in 1974?
Offer a very short reply. 0.76. What is the ratio of the Emissions(kt) in Australia in 1969 to that in 1975?
Make the answer very short. 0.79. What is the ratio of the Emissions(kt) of Cabo Verde in 1969 to that in 1975?
Offer a very short reply. 0.38. What is the ratio of the Emissions(kt) in Suriname in 1969 to that in 1975?
Offer a very short reply. 0.76. What is the ratio of the Emissions(kt) of Tunisia in 1969 to that in 1975?
Offer a very short reply. 0.73. What is the ratio of the Emissions(kt) of Australia in 1969 to that in 1976?
Keep it short and to the point. 0.84. What is the ratio of the Emissions(kt) of Suriname in 1969 to that in 1976?
Make the answer very short. 0.77. What is the ratio of the Emissions(kt) of Tunisia in 1969 to that in 1976?
Keep it short and to the point. 0.67. What is the ratio of the Emissions(kt) in Australia in 1970 to that in 1971?
Keep it short and to the point. 0.95. What is the ratio of the Emissions(kt) in Cabo Verde in 1970 to that in 1971?
Your answer should be compact. 0.89. What is the ratio of the Emissions(kt) of Suriname in 1970 to that in 1971?
Your response must be concise. 0.95. What is the ratio of the Emissions(kt) in Tunisia in 1970 to that in 1971?
Your response must be concise. 0.84. What is the ratio of the Emissions(kt) of Australia in 1970 to that in 1972?
Ensure brevity in your answer.  0.96. What is the ratio of the Emissions(kt) in Cabo Verde in 1970 to that in 1972?
Offer a terse response. 0.62. What is the ratio of the Emissions(kt) of Suriname in 1970 to that in 1972?
Give a very brief answer. 0.94. What is the ratio of the Emissions(kt) of Tunisia in 1970 to that in 1972?
Keep it short and to the point. 0.78. What is the ratio of the Emissions(kt) of Australia in 1970 to that in 1973?
Keep it short and to the point. 0.83. What is the ratio of the Emissions(kt) of Cabo Verde in 1970 to that in 1973?
Make the answer very short. 0.53. What is the ratio of the Emissions(kt) in Suriname in 1970 to that in 1973?
Your answer should be compact. 0.77. What is the ratio of the Emissions(kt) in Tunisia in 1970 to that in 1973?
Offer a terse response. 0.77. What is the ratio of the Emissions(kt) of Australia in 1970 to that in 1974?
Make the answer very short. 0.89. What is the ratio of the Emissions(kt) in Cabo Verde in 1970 to that in 1974?
Ensure brevity in your answer.  0.44. What is the ratio of the Emissions(kt) in Suriname in 1970 to that in 1974?
Give a very brief answer. 1.03. What is the ratio of the Emissions(kt) of Tunisia in 1970 to that in 1974?
Ensure brevity in your answer.  0.73. What is the ratio of the Emissions(kt) in Australia in 1970 to that in 1975?
Make the answer very short. 0.88. What is the ratio of the Emissions(kt) in Cabo Verde in 1970 to that in 1975?
Ensure brevity in your answer.  0.38. What is the ratio of the Emissions(kt) of Suriname in 1970 to that in 1975?
Make the answer very short. 0.8. What is the ratio of the Emissions(kt) of Tunisia in 1970 to that in 1975?
Your answer should be very brief. 0.7. What is the ratio of the Emissions(kt) in Australia in 1970 to that in 1976?
Your response must be concise. 0.93. What is the ratio of the Emissions(kt) in Suriname in 1970 to that in 1976?
Keep it short and to the point. 0.81. What is the ratio of the Emissions(kt) in Tunisia in 1970 to that in 1976?
Your answer should be compact. 0.64. What is the ratio of the Emissions(kt) of Australia in 1971 to that in 1972?
Provide a short and direct response. 1.01. What is the ratio of the Emissions(kt) in Cabo Verde in 1971 to that in 1972?
Give a very brief answer. 0.69. What is the ratio of the Emissions(kt) of Suriname in 1971 to that in 1972?
Offer a very short reply. 0.98. What is the ratio of the Emissions(kt) of Tunisia in 1971 to that in 1972?
Make the answer very short. 0.92. What is the ratio of the Emissions(kt) in Australia in 1971 to that in 1973?
Offer a very short reply. 0.88. What is the ratio of the Emissions(kt) in Cabo Verde in 1971 to that in 1973?
Give a very brief answer. 0.6. What is the ratio of the Emissions(kt) of Suriname in 1971 to that in 1973?
Your answer should be compact. 0.81. What is the ratio of the Emissions(kt) in Tunisia in 1971 to that in 1973?
Provide a succinct answer. 0.92. What is the ratio of the Emissions(kt) in Australia in 1971 to that in 1974?
Your answer should be compact. 0.94. What is the ratio of the Emissions(kt) of Cabo Verde in 1971 to that in 1974?
Keep it short and to the point. 0.5. What is the ratio of the Emissions(kt) of Suriname in 1971 to that in 1974?
Keep it short and to the point. 1.08. What is the ratio of the Emissions(kt) in Tunisia in 1971 to that in 1974?
Provide a short and direct response. 0.87. What is the ratio of the Emissions(kt) in Australia in 1971 to that in 1975?
Offer a very short reply. 0.92. What is the ratio of the Emissions(kt) in Cabo Verde in 1971 to that in 1975?
Provide a succinct answer. 0.43. What is the ratio of the Emissions(kt) in Suriname in 1971 to that in 1975?
Your answer should be very brief. 0.84. What is the ratio of the Emissions(kt) of Tunisia in 1971 to that in 1975?
Your answer should be compact. 0.83. What is the ratio of the Emissions(kt) of Australia in 1971 to that in 1976?
Make the answer very short. 0.98. What is the ratio of the Emissions(kt) of Cabo Verde in 1971 to that in 1976?
Provide a short and direct response. 0.45. What is the ratio of the Emissions(kt) in Suriname in 1971 to that in 1976?
Provide a succinct answer. 0.85. What is the ratio of the Emissions(kt) in Tunisia in 1971 to that in 1976?
Keep it short and to the point. 0.76. What is the ratio of the Emissions(kt) of Australia in 1972 to that in 1973?
Provide a succinct answer. 0.87. What is the ratio of the Emissions(kt) in Cabo Verde in 1972 to that in 1973?
Give a very brief answer. 0.87. What is the ratio of the Emissions(kt) of Suriname in 1972 to that in 1973?
Provide a succinct answer. 0.82. What is the ratio of the Emissions(kt) in Australia in 1972 to that in 1974?
Offer a very short reply. 0.93. What is the ratio of the Emissions(kt) in Cabo Verde in 1972 to that in 1974?
Provide a short and direct response. 0.72. What is the ratio of the Emissions(kt) in Suriname in 1972 to that in 1974?
Offer a terse response. 1.1. What is the ratio of the Emissions(kt) in Tunisia in 1972 to that in 1974?
Offer a terse response. 0.94. What is the ratio of the Emissions(kt) of Australia in 1972 to that in 1975?
Keep it short and to the point. 0.92. What is the ratio of the Emissions(kt) in Cabo Verde in 1972 to that in 1975?
Give a very brief answer. 0.62. What is the ratio of the Emissions(kt) in Suriname in 1972 to that in 1975?
Your answer should be very brief. 0.85. What is the ratio of the Emissions(kt) of Tunisia in 1972 to that in 1975?
Offer a very short reply. 0.9. What is the ratio of the Emissions(kt) of Australia in 1972 to that in 1976?
Ensure brevity in your answer.  0.97. What is the ratio of the Emissions(kt) of Cabo Verde in 1972 to that in 1976?
Provide a succinct answer. 0.65. What is the ratio of the Emissions(kt) in Suriname in 1972 to that in 1976?
Your answer should be very brief. 0.86. What is the ratio of the Emissions(kt) of Tunisia in 1972 to that in 1976?
Your response must be concise. 0.83. What is the ratio of the Emissions(kt) in Australia in 1973 to that in 1974?
Your answer should be compact. 1.07. What is the ratio of the Emissions(kt) of Suriname in 1973 to that in 1974?
Your answer should be compact. 1.34. What is the ratio of the Emissions(kt) of Tunisia in 1973 to that in 1974?
Keep it short and to the point. 0.95. What is the ratio of the Emissions(kt) in Australia in 1973 to that in 1975?
Provide a succinct answer. 1.05. What is the ratio of the Emissions(kt) of Cabo Verde in 1973 to that in 1975?
Provide a succinct answer. 0.71. What is the ratio of the Emissions(kt) of Suriname in 1973 to that in 1975?
Offer a terse response. 1.04. What is the ratio of the Emissions(kt) in Tunisia in 1973 to that in 1975?
Provide a short and direct response. 0.9. What is the ratio of the Emissions(kt) of Australia in 1973 to that in 1976?
Provide a succinct answer. 1.12. What is the ratio of the Emissions(kt) of Cabo Verde in 1973 to that in 1976?
Provide a succinct answer. 0.75. What is the ratio of the Emissions(kt) of Suriname in 1973 to that in 1976?
Your answer should be very brief. 1.05. What is the ratio of the Emissions(kt) of Tunisia in 1973 to that in 1976?
Keep it short and to the point. 0.83. What is the ratio of the Emissions(kt) of Australia in 1974 to that in 1975?
Make the answer very short. 0.98. What is the ratio of the Emissions(kt) in Cabo Verde in 1974 to that in 1975?
Your answer should be very brief. 0.86. What is the ratio of the Emissions(kt) in Suriname in 1974 to that in 1975?
Give a very brief answer. 0.77. What is the ratio of the Emissions(kt) of Tunisia in 1974 to that in 1975?
Your response must be concise. 0.95. What is the ratio of the Emissions(kt) of Australia in 1974 to that in 1976?
Your answer should be compact. 1.04. What is the ratio of the Emissions(kt) of Cabo Verde in 1974 to that in 1976?
Offer a terse response. 0.9. What is the ratio of the Emissions(kt) in Suriname in 1974 to that in 1976?
Offer a terse response. 0.78. What is the ratio of the Emissions(kt) of Tunisia in 1974 to that in 1976?
Your answer should be compact. 0.88. What is the ratio of the Emissions(kt) in Australia in 1975 to that in 1976?
Make the answer very short. 1.06. What is the ratio of the Emissions(kt) in Cabo Verde in 1975 to that in 1976?
Keep it short and to the point. 1.05. What is the ratio of the Emissions(kt) in Suriname in 1975 to that in 1976?
Make the answer very short. 1.01. What is the ratio of the Emissions(kt) of Tunisia in 1975 to that in 1976?
Your answer should be very brief. 0.92. What is the difference between the highest and the second highest Emissions(kt) of Australia?
Make the answer very short. 4110.71. What is the difference between the highest and the second highest Emissions(kt) in Cabo Verde?
Your answer should be very brief. 3.67. What is the difference between the highest and the second highest Emissions(kt) of Suriname?
Your answer should be very brief. 69.67. What is the difference between the highest and the second highest Emissions(kt) in Tunisia?
Ensure brevity in your answer.  385.04. What is the difference between the highest and the lowest Emissions(kt) of Australia?
Make the answer very short. 2.05e+04. What is the difference between the highest and the lowest Emissions(kt) in Cabo Verde?
Provide a succinct answer. 47.67. What is the difference between the highest and the lowest Emissions(kt) of Suriname?
Make the answer very short. 535.38. What is the difference between the highest and the lowest Emissions(kt) of Tunisia?
Provide a succinct answer. 1712.49. 